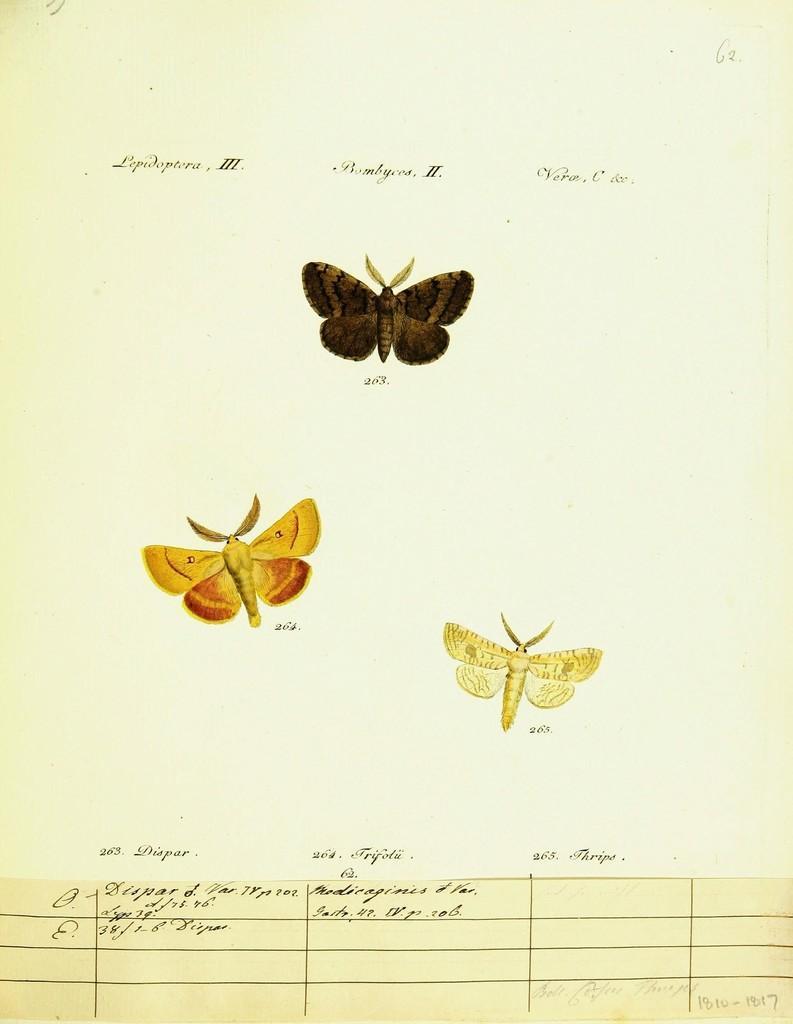Could you give a brief overview of what you see in this image? In this picture we can see images of butterflies and text on a paper. 